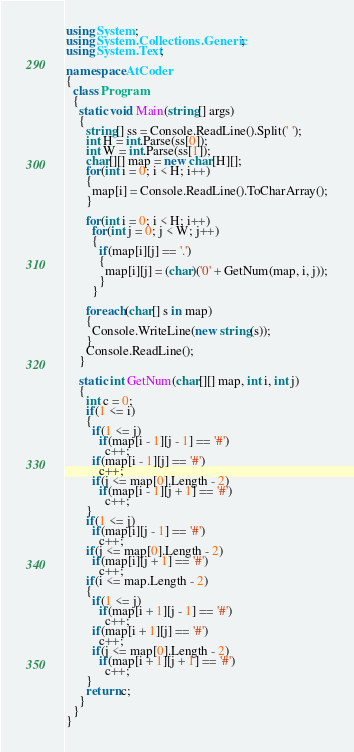Convert code to text. <code><loc_0><loc_0><loc_500><loc_500><_C#_>using System;
using System.Collections.Generic;
using System.Text;

namespace AtCoder
{
  class Program
  {
    static void Main(string[] args)
    {
      string[] ss = Console.ReadLine().Split(' ');
      int H = int.Parse(ss[0]);
      int W = int.Parse(ss[1]);
      char[][] map = new char[H][];
      for(int i = 0; i < H; i++)
      {
        map[i] = Console.ReadLine().ToCharArray();
      }

      for(int i = 0; i < H; i++)
        for(int j = 0; j < W; j++)
        {
          if(map[i][j] == '.')
          {
            map[i][j] = (char)('0' + GetNum(map, i, j));
          }
        }

      foreach(char[] s in map)
      {
        Console.WriteLine(new string(s));
      }
      Console.ReadLine();
    }

    static int GetNum(char[][] map, int i, int j)
    {
      int c = 0;
      if(1 <= i)
      {
        if(1 <= j)
          if(map[i - 1][j - 1] == '#')
            c++;
        if(map[i - 1][j] == '#')
          c++;
        if(j <= map[0].Length - 2)
          if(map[i - 1][j + 1] == '#')
            c++;
      }
      if(1 <= j)
        if(map[i][j - 1] == '#')
          c++;
      if(j <= map[0].Length - 2)
        if(map[i][j + 1] == '#')
          c++;
      if(i <= map.Length - 2)
      {
        if(1 <= j)
          if(map[i + 1][j - 1] == '#')
            c++;
        if(map[i + 1][j] == '#')
          c++;
        if(j <= map[0].Length - 2)
          if(map[i + 1][j + 1] == '#')
            c++;
      }
      return c;
    }
  }
}</code> 